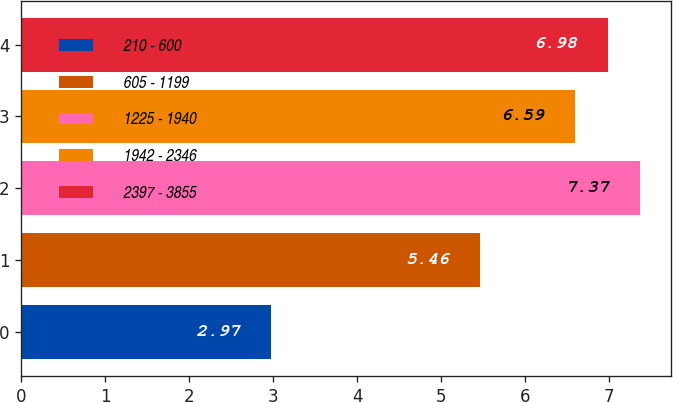Convert chart to OTSL. <chart><loc_0><loc_0><loc_500><loc_500><bar_chart><fcel>210 - 600<fcel>605 - 1199<fcel>1225 - 1940<fcel>1942 - 2346<fcel>2397 - 3855<nl><fcel>2.97<fcel>5.46<fcel>7.37<fcel>6.59<fcel>6.98<nl></chart> 